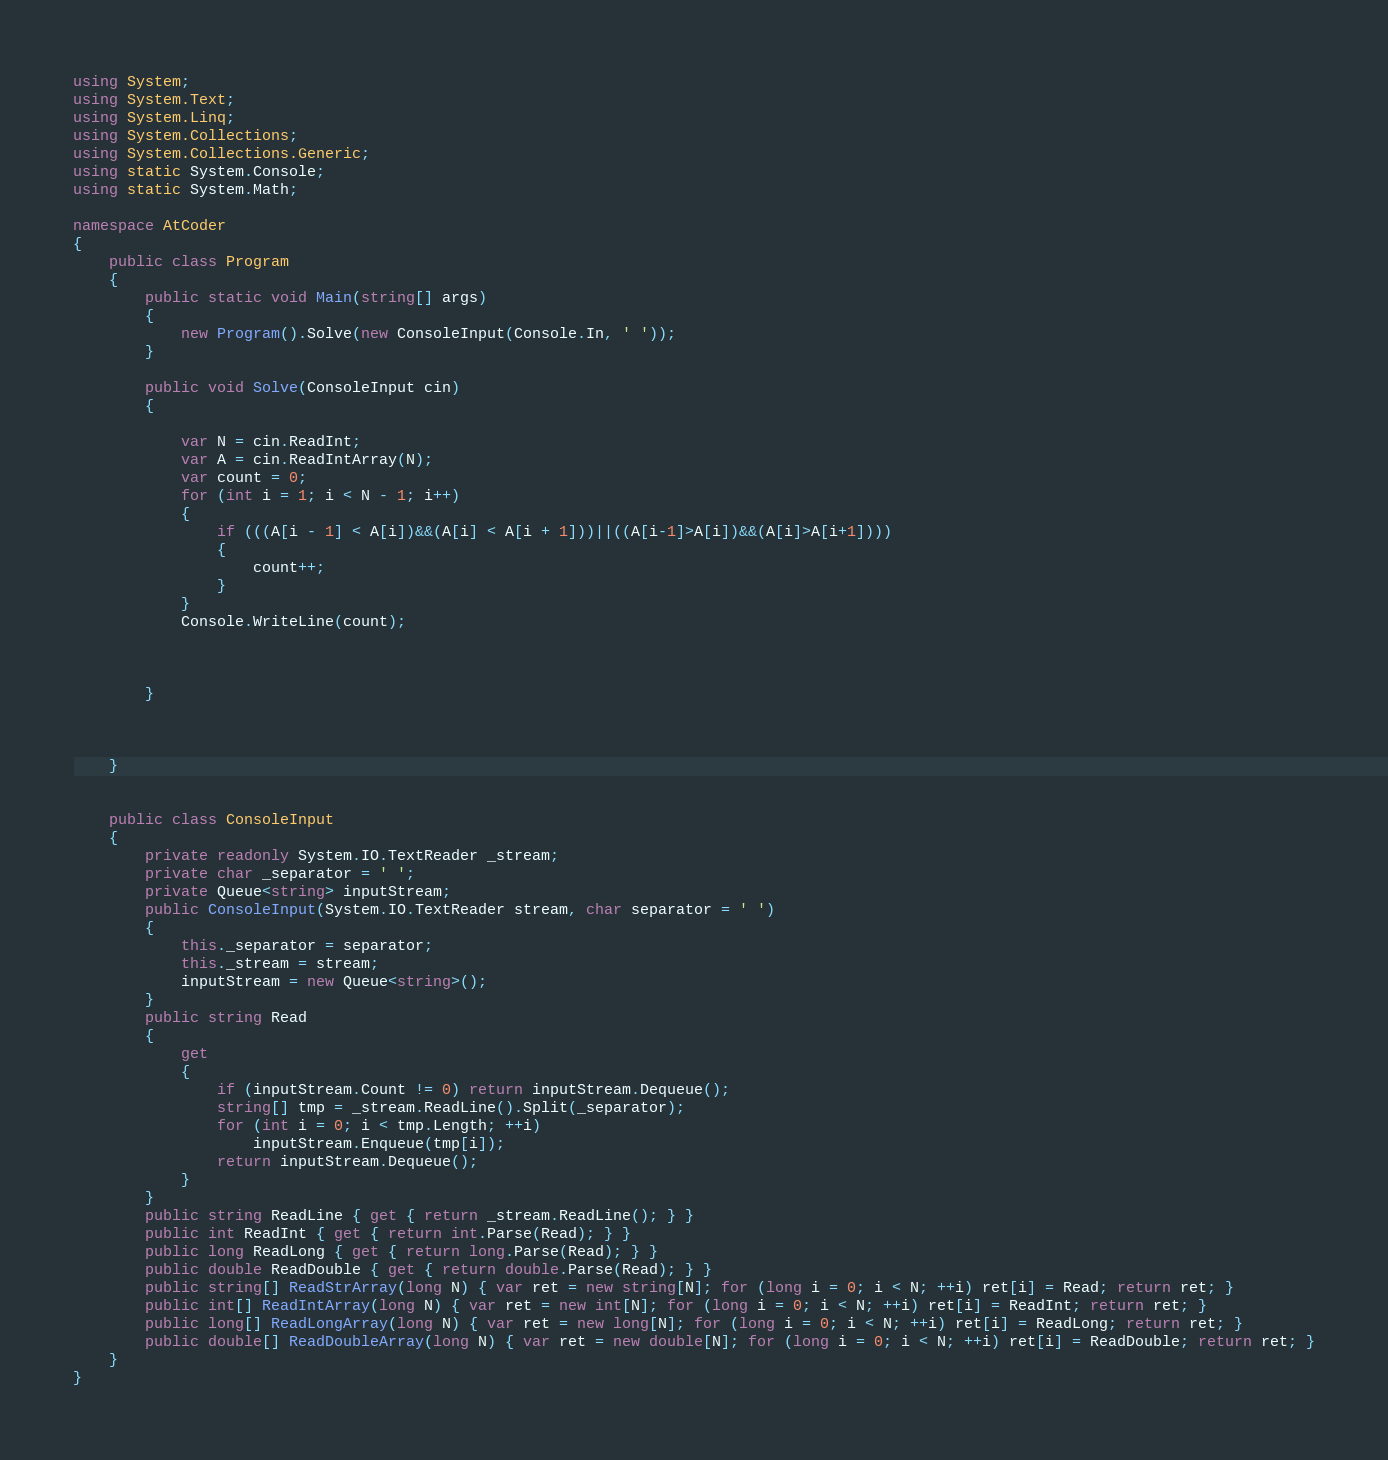<code> <loc_0><loc_0><loc_500><loc_500><_C#_>using System;
using System.Text;
using System.Linq;
using System.Collections;
using System.Collections.Generic;
using static System.Console;
using static System.Math;

namespace AtCoder
{
    public class Program
    {
        public static void Main(string[] args)
        {
            new Program().Solve(new ConsoleInput(Console.In, ' '));
        }

        public void Solve(ConsoleInput cin)
        {

            var N = cin.ReadInt;
            var A = cin.ReadIntArray(N);
            var count = 0;
            for (int i = 1; i < N - 1; i++)
            {
                if (((A[i - 1] < A[i])&&(A[i] < A[i + 1]))||((A[i-1]>A[i])&&(A[i]>A[i+1])))
                {
                    count++;
                }
            }
            Console.WriteLine(count);
            
            
            
        }



    }
    

    public class ConsoleInput
    {
        private readonly System.IO.TextReader _stream;
        private char _separator = ' ';
        private Queue<string> inputStream;
        public ConsoleInput(System.IO.TextReader stream, char separator = ' ')
        {
            this._separator = separator;
            this._stream = stream;
            inputStream = new Queue<string>();
        }
        public string Read
        {
            get
            {
                if (inputStream.Count != 0) return inputStream.Dequeue();
                string[] tmp = _stream.ReadLine().Split(_separator);
                for (int i = 0; i < tmp.Length; ++i)
                    inputStream.Enqueue(tmp[i]);
                return inputStream.Dequeue();
            }
        }
        public string ReadLine { get { return _stream.ReadLine(); } }
        public int ReadInt { get { return int.Parse(Read); } }
        public long ReadLong { get { return long.Parse(Read); } }
        public double ReadDouble { get { return double.Parse(Read); } }
        public string[] ReadStrArray(long N) { var ret = new string[N]; for (long i = 0; i < N; ++i) ret[i] = Read; return ret; }
        public int[] ReadIntArray(long N) { var ret = new int[N]; for (long i = 0; i < N; ++i) ret[i] = ReadInt; return ret; }
        public long[] ReadLongArray(long N) { var ret = new long[N]; for (long i = 0; i < N; ++i) ret[i] = ReadLong; return ret; }
        public double[] ReadDoubleArray(long N) { var ret = new double[N]; for (long i = 0; i < N; ++i) ret[i] = ReadDouble; return ret; }
    }
}</code> 